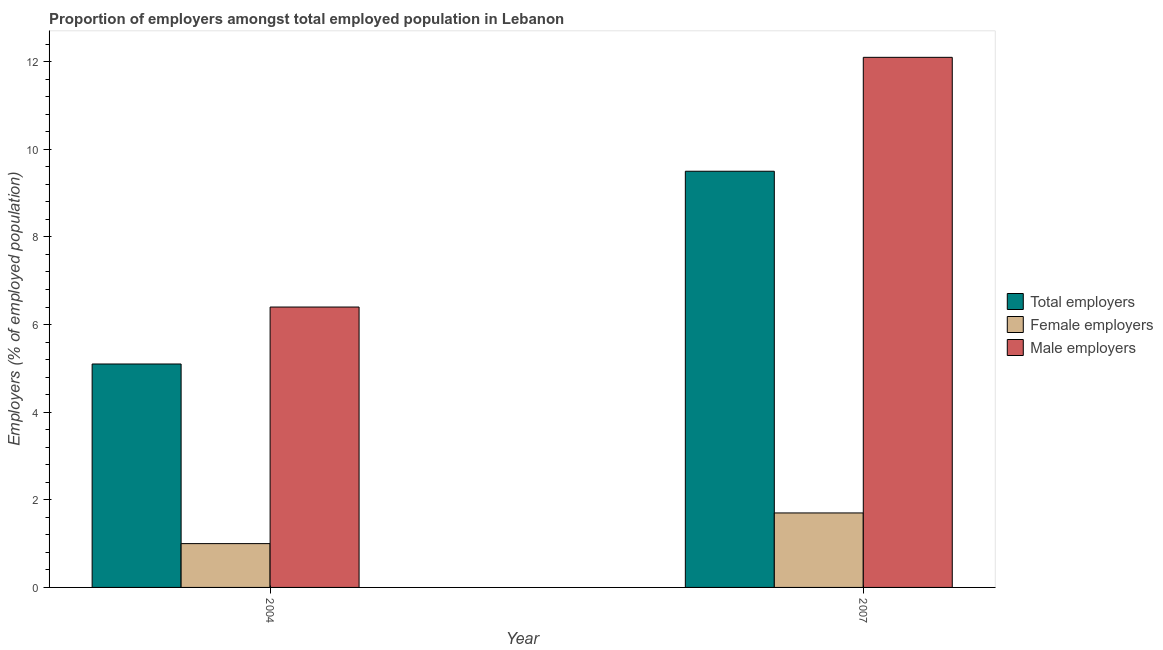Are the number of bars per tick equal to the number of legend labels?
Provide a succinct answer. Yes. How many bars are there on the 2nd tick from the left?
Your response must be concise. 3. How many bars are there on the 2nd tick from the right?
Ensure brevity in your answer.  3. What is the percentage of total employers in 2007?
Offer a terse response. 9.5. Across all years, what is the minimum percentage of female employers?
Keep it short and to the point. 1. In which year was the percentage of male employers minimum?
Give a very brief answer. 2004. What is the total percentage of female employers in the graph?
Offer a terse response. 2.7. What is the difference between the percentage of female employers in 2004 and that in 2007?
Keep it short and to the point. -0.7. What is the difference between the percentage of total employers in 2007 and the percentage of male employers in 2004?
Provide a succinct answer. 4.4. What is the average percentage of total employers per year?
Your response must be concise. 7.3. In the year 2007, what is the difference between the percentage of male employers and percentage of female employers?
Your response must be concise. 0. In how many years, is the percentage of total employers greater than 3.6 %?
Your answer should be very brief. 2. What is the ratio of the percentage of male employers in 2004 to that in 2007?
Your answer should be very brief. 0.53. What does the 1st bar from the left in 2007 represents?
Provide a succinct answer. Total employers. What does the 2nd bar from the right in 2004 represents?
Your answer should be very brief. Female employers. How many years are there in the graph?
Provide a short and direct response. 2. What is the difference between two consecutive major ticks on the Y-axis?
Your answer should be very brief. 2. What is the title of the graph?
Give a very brief answer. Proportion of employers amongst total employed population in Lebanon. Does "Ireland" appear as one of the legend labels in the graph?
Provide a short and direct response. No. What is the label or title of the X-axis?
Keep it short and to the point. Year. What is the label or title of the Y-axis?
Your answer should be very brief. Employers (% of employed population). What is the Employers (% of employed population) of Total employers in 2004?
Ensure brevity in your answer.  5.1. What is the Employers (% of employed population) in Male employers in 2004?
Provide a short and direct response. 6.4. What is the Employers (% of employed population) in Total employers in 2007?
Ensure brevity in your answer.  9.5. What is the Employers (% of employed population) of Female employers in 2007?
Your response must be concise. 1.7. What is the Employers (% of employed population) in Male employers in 2007?
Your response must be concise. 12.1. Across all years, what is the maximum Employers (% of employed population) of Total employers?
Provide a short and direct response. 9.5. Across all years, what is the maximum Employers (% of employed population) of Female employers?
Give a very brief answer. 1.7. Across all years, what is the maximum Employers (% of employed population) of Male employers?
Give a very brief answer. 12.1. Across all years, what is the minimum Employers (% of employed population) of Total employers?
Keep it short and to the point. 5.1. Across all years, what is the minimum Employers (% of employed population) in Female employers?
Your response must be concise. 1. Across all years, what is the minimum Employers (% of employed population) of Male employers?
Your answer should be very brief. 6.4. What is the total Employers (% of employed population) of Total employers in the graph?
Provide a short and direct response. 14.6. What is the total Employers (% of employed population) of Female employers in the graph?
Give a very brief answer. 2.7. What is the total Employers (% of employed population) in Male employers in the graph?
Give a very brief answer. 18.5. What is the difference between the Employers (% of employed population) in Total employers in 2004 and that in 2007?
Provide a short and direct response. -4.4. What is the difference between the Employers (% of employed population) of Total employers in 2004 and the Employers (% of employed population) of Male employers in 2007?
Give a very brief answer. -7. What is the average Employers (% of employed population) of Total employers per year?
Your response must be concise. 7.3. What is the average Employers (% of employed population) in Female employers per year?
Offer a very short reply. 1.35. What is the average Employers (% of employed population) of Male employers per year?
Give a very brief answer. 9.25. In the year 2004, what is the difference between the Employers (% of employed population) in Total employers and Employers (% of employed population) in Male employers?
Ensure brevity in your answer.  -1.3. In the year 2004, what is the difference between the Employers (% of employed population) of Female employers and Employers (% of employed population) of Male employers?
Give a very brief answer. -5.4. In the year 2007, what is the difference between the Employers (% of employed population) in Total employers and Employers (% of employed population) in Male employers?
Keep it short and to the point. -2.6. What is the ratio of the Employers (% of employed population) in Total employers in 2004 to that in 2007?
Offer a terse response. 0.54. What is the ratio of the Employers (% of employed population) in Female employers in 2004 to that in 2007?
Offer a terse response. 0.59. What is the ratio of the Employers (% of employed population) of Male employers in 2004 to that in 2007?
Make the answer very short. 0.53. What is the difference between the highest and the second highest Employers (% of employed population) in Total employers?
Give a very brief answer. 4.4. What is the difference between the highest and the second highest Employers (% of employed population) of Female employers?
Ensure brevity in your answer.  0.7. What is the difference between the highest and the second highest Employers (% of employed population) of Male employers?
Ensure brevity in your answer.  5.7. What is the difference between the highest and the lowest Employers (% of employed population) in Total employers?
Provide a short and direct response. 4.4. 